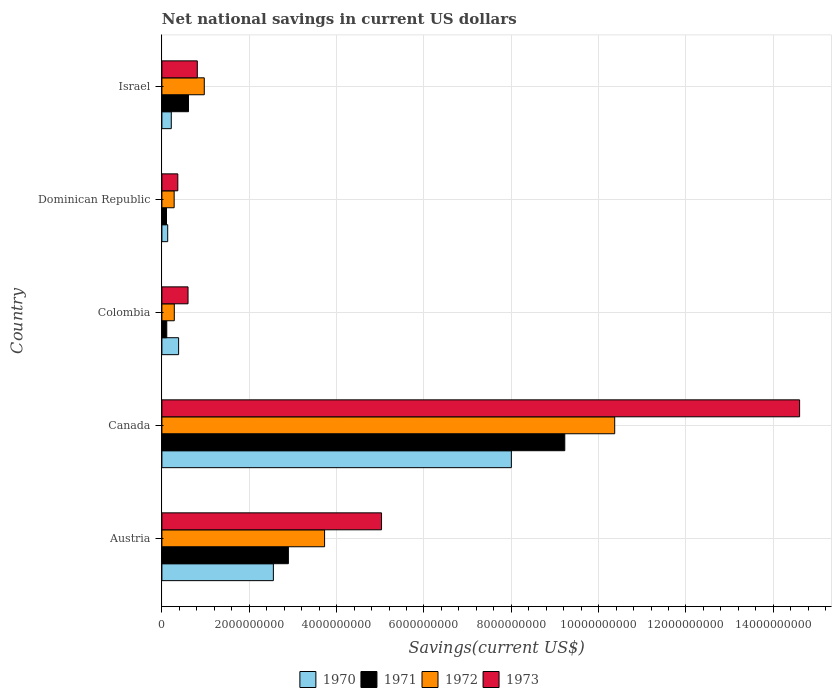How many different coloured bars are there?
Keep it short and to the point. 4. Are the number of bars per tick equal to the number of legend labels?
Provide a short and direct response. Yes. Are the number of bars on each tick of the Y-axis equal?
Ensure brevity in your answer.  Yes. How many bars are there on the 3rd tick from the top?
Your answer should be compact. 4. What is the label of the 4th group of bars from the top?
Ensure brevity in your answer.  Canada. In how many cases, is the number of bars for a given country not equal to the number of legend labels?
Your response must be concise. 0. What is the net national savings in 1970 in Dominican Republic?
Your response must be concise. 1.33e+08. Across all countries, what is the maximum net national savings in 1973?
Keep it short and to the point. 1.46e+1. Across all countries, what is the minimum net national savings in 1972?
Offer a very short reply. 2.80e+08. In which country was the net national savings in 1973 maximum?
Your answer should be very brief. Canada. In which country was the net national savings in 1972 minimum?
Provide a succinct answer. Dominican Republic. What is the total net national savings in 1973 in the graph?
Offer a terse response. 2.14e+1. What is the difference between the net national savings in 1973 in Canada and that in Israel?
Make the answer very short. 1.38e+1. What is the difference between the net national savings in 1971 in Israel and the net national savings in 1972 in Canada?
Provide a succinct answer. -9.76e+09. What is the average net national savings in 1973 per country?
Keep it short and to the point. 4.28e+09. What is the difference between the net national savings in 1970 and net national savings in 1971 in Colombia?
Offer a very short reply. 2.71e+08. What is the ratio of the net national savings in 1971 in Canada to that in Dominican Republic?
Your answer should be compact. 87.52. Is the difference between the net national savings in 1970 in Canada and Israel greater than the difference between the net national savings in 1971 in Canada and Israel?
Give a very brief answer. No. What is the difference between the highest and the second highest net national savings in 1972?
Your answer should be compact. 6.64e+09. What is the difference between the highest and the lowest net national savings in 1972?
Ensure brevity in your answer.  1.01e+1. Is it the case that in every country, the sum of the net national savings in 1970 and net national savings in 1973 is greater than the sum of net national savings in 1972 and net national savings in 1971?
Offer a terse response. No. What does the 2nd bar from the bottom in Canada represents?
Give a very brief answer. 1971. Is it the case that in every country, the sum of the net national savings in 1972 and net national savings in 1970 is greater than the net national savings in 1973?
Ensure brevity in your answer.  Yes. How many bars are there?
Your answer should be very brief. 20. Are all the bars in the graph horizontal?
Keep it short and to the point. Yes. How many countries are there in the graph?
Your answer should be very brief. 5. Are the values on the major ticks of X-axis written in scientific E-notation?
Provide a short and direct response. No. How many legend labels are there?
Give a very brief answer. 4. What is the title of the graph?
Keep it short and to the point. Net national savings in current US dollars. Does "2002" appear as one of the legend labels in the graph?
Ensure brevity in your answer.  No. What is the label or title of the X-axis?
Offer a terse response. Savings(current US$). What is the label or title of the Y-axis?
Offer a very short reply. Country. What is the Savings(current US$) of 1970 in Austria?
Give a very brief answer. 2.55e+09. What is the Savings(current US$) of 1971 in Austria?
Provide a short and direct response. 2.90e+09. What is the Savings(current US$) of 1972 in Austria?
Give a very brief answer. 3.73e+09. What is the Savings(current US$) of 1973 in Austria?
Your response must be concise. 5.03e+09. What is the Savings(current US$) of 1970 in Canada?
Ensure brevity in your answer.  8.00e+09. What is the Savings(current US$) of 1971 in Canada?
Offer a very short reply. 9.23e+09. What is the Savings(current US$) of 1972 in Canada?
Give a very brief answer. 1.04e+1. What is the Savings(current US$) in 1973 in Canada?
Give a very brief answer. 1.46e+1. What is the Savings(current US$) of 1970 in Colombia?
Offer a very short reply. 3.83e+08. What is the Savings(current US$) of 1971 in Colombia?
Offer a very short reply. 1.11e+08. What is the Savings(current US$) of 1972 in Colombia?
Your response must be concise. 2.84e+08. What is the Savings(current US$) of 1973 in Colombia?
Provide a short and direct response. 5.98e+08. What is the Savings(current US$) in 1970 in Dominican Republic?
Give a very brief answer. 1.33e+08. What is the Savings(current US$) in 1971 in Dominican Republic?
Make the answer very short. 1.05e+08. What is the Savings(current US$) in 1972 in Dominican Republic?
Give a very brief answer. 2.80e+08. What is the Savings(current US$) in 1973 in Dominican Republic?
Provide a succinct answer. 3.65e+08. What is the Savings(current US$) of 1970 in Israel?
Keep it short and to the point. 2.15e+08. What is the Savings(current US$) of 1971 in Israel?
Ensure brevity in your answer.  6.09e+08. What is the Savings(current US$) of 1972 in Israel?
Your answer should be compact. 9.71e+08. What is the Savings(current US$) in 1973 in Israel?
Offer a very short reply. 8.11e+08. Across all countries, what is the maximum Savings(current US$) in 1970?
Your answer should be compact. 8.00e+09. Across all countries, what is the maximum Savings(current US$) of 1971?
Your response must be concise. 9.23e+09. Across all countries, what is the maximum Savings(current US$) of 1972?
Offer a terse response. 1.04e+1. Across all countries, what is the maximum Savings(current US$) in 1973?
Your answer should be very brief. 1.46e+1. Across all countries, what is the minimum Savings(current US$) of 1970?
Keep it short and to the point. 1.33e+08. Across all countries, what is the minimum Savings(current US$) in 1971?
Your response must be concise. 1.05e+08. Across all countries, what is the minimum Savings(current US$) of 1972?
Keep it short and to the point. 2.80e+08. Across all countries, what is the minimum Savings(current US$) in 1973?
Provide a short and direct response. 3.65e+08. What is the total Savings(current US$) of 1970 in the graph?
Keep it short and to the point. 1.13e+1. What is the total Savings(current US$) in 1971 in the graph?
Keep it short and to the point. 1.29e+1. What is the total Savings(current US$) in 1972 in the graph?
Provide a short and direct response. 1.56e+1. What is the total Savings(current US$) of 1973 in the graph?
Offer a very short reply. 2.14e+1. What is the difference between the Savings(current US$) in 1970 in Austria and that in Canada?
Provide a succinct answer. -5.45e+09. What is the difference between the Savings(current US$) of 1971 in Austria and that in Canada?
Offer a terse response. -6.33e+09. What is the difference between the Savings(current US$) in 1972 in Austria and that in Canada?
Give a very brief answer. -6.64e+09. What is the difference between the Savings(current US$) in 1973 in Austria and that in Canada?
Provide a succinct answer. -9.57e+09. What is the difference between the Savings(current US$) in 1970 in Austria and that in Colombia?
Give a very brief answer. 2.17e+09. What is the difference between the Savings(current US$) in 1971 in Austria and that in Colombia?
Offer a very short reply. 2.78e+09. What is the difference between the Savings(current US$) of 1972 in Austria and that in Colombia?
Provide a short and direct response. 3.44e+09. What is the difference between the Savings(current US$) in 1973 in Austria and that in Colombia?
Give a very brief answer. 4.43e+09. What is the difference between the Savings(current US$) in 1970 in Austria and that in Dominican Republic?
Make the answer very short. 2.42e+09. What is the difference between the Savings(current US$) of 1971 in Austria and that in Dominican Republic?
Keep it short and to the point. 2.79e+09. What is the difference between the Savings(current US$) of 1972 in Austria and that in Dominican Republic?
Your response must be concise. 3.44e+09. What is the difference between the Savings(current US$) of 1973 in Austria and that in Dominican Republic?
Give a very brief answer. 4.66e+09. What is the difference between the Savings(current US$) in 1970 in Austria and that in Israel?
Give a very brief answer. 2.34e+09. What is the difference between the Savings(current US$) in 1971 in Austria and that in Israel?
Keep it short and to the point. 2.29e+09. What is the difference between the Savings(current US$) in 1972 in Austria and that in Israel?
Ensure brevity in your answer.  2.75e+09. What is the difference between the Savings(current US$) of 1973 in Austria and that in Israel?
Ensure brevity in your answer.  4.22e+09. What is the difference between the Savings(current US$) of 1970 in Canada and that in Colombia?
Offer a terse response. 7.62e+09. What is the difference between the Savings(current US$) of 1971 in Canada and that in Colombia?
Offer a very short reply. 9.11e+09. What is the difference between the Savings(current US$) in 1972 in Canada and that in Colombia?
Make the answer very short. 1.01e+1. What is the difference between the Savings(current US$) in 1973 in Canada and that in Colombia?
Provide a succinct answer. 1.40e+1. What is the difference between the Savings(current US$) of 1970 in Canada and that in Dominican Republic?
Your answer should be very brief. 7.87e+09. What is the difference between the Savings(current US$) of 1971 in Canada and that in Dominican Republic?
Your response must be concise. 9.12e+09. What is the difference between the Savings(current US$) in 1972 in Canada and that in Dominican Republic?
Keep it short and to the point. 1.01e+1. What is the difference between the Savings(current US$) of 1973 in Canada and that in Dominican Republic?
Make the answer very short. 1.42e+1. What is the difference between the Savings(current US$) of 1970 in Canada and that in Israel?
Offer a very short reply. 7.79e+09. What is the difference between the Savings(current US$) of 1971 in Canada and that in Israel?
Give a very brief answer. 8.62e+09. What is the difference between the Savings(current US$) of 1972 in Canada and that in Israel?
Give a very brief answer. 9.40e+09. What is the difference between the Savings(current US$) in 1973 in Canada and that in Israel?
Offer a very short reply. 1.38e+1. What is the difference between the Savings(current US$) of 1970 in Colombia and that in Dominican Republic?
Your answer should be very brief. 2.50e+08. What is the difference between the Savings(current US$) in 1971 in Colombia and that in Dominican Republic?
Make the answer very short. 6.03e+06. What is the difference between the Savings(current US$) of 1972 in Colombia and that in Dominican Republic?
Offer a terse response. 3.48e+06. What is the difference between the Savings(current US$) in 1973 in Colombia and that in Dominican Republic?
Make the answer very short. 2.34e+08. What is the difference between the Savings(current US$) of 1970 in Colombia and that in Israel?
Provide a succinct answer. 1.68e+08. What is the difference between the Savings(current US$) in 1971 in Colombia and that in Israel?
Provide a succinct answer. -4.97e+08. What is the difference between the Savings(current US$) in 1972 in Colombia and that in Israel?
Ensure brevity in your answer.  -6.87e+08. What is the difference between the Savings(current US$) of 1973 in Colombia and that in Israel?
Provide a succinct answer. -2.12e+08. What is the difference between the Savings(current US$) of 1970 in Dominican Republic and that in Israel?
Ensure brevity in your answer.  -8.19e+07. What is the difference between the Savings(current US$) in 1971 in Dominican Republic and that in Israel?
Keep it short and to the point. -5.03e+08. What is the difference between the Savings(current US$) in 1972 in Dominican Republic and that in Israel?
Offer a terse response. -6.90e+08. What is the difference between the Savings(current US$) in 1973 in Dominican Republic and that in Israel?
Give a very brief answer. -4.46e+08. What is the difference between the Savings(current US$) of 1970 in Austria and the Savings(current US$) of 1971 in Canada?
Provide a short and direct response. -6.67e+09. What is the difference between the Savings(current US$) in 1970 in Austria and the Savings(current US$) in 1972 in Canada?
Your answer should be compact. -7.82e+09. What is the difference between the Savings(current US$) of 1970 in Austria and the Savings(current US$) of 1973 in Canada?
Make the answer very short. -1.20e+1. What is the difference between the Savings(current US$) in 1971 in Austria and the Savings(current US$) in 1972 in Canada?
Provide a short and direct response. -7.47e+09. What is the difference between the Savings(current US$) in 1971 in Austria and the Savings(current US$) in 1973 in Canada?
Ensure brevity in your answer.  -1.17e+1. What is the difference between the Savings(current US$) in 1972 in Austria and the Savings(current US$) in 1973 in Canada?
Ensure brevity in your answer.  -1.09e+1. What is the difference between the Savings(current US$) of 1970 in Austria and the Savings(current US$) of 1971 in Colombia?
Offer a very short reply. 2.44e+09. What is the difference between the Savings(current US$) in 1970 in Austria and the Savings(current US$) in 1972 in Colombia?
Ensure brevity in your answer.  2.27e+09. What is the difference between the Savings(current US$) of 1970 in Austria and the Savings(current US$) of 1973 in Colombia?
Provide a succinct answer. 1.95e+09. What is the difference between the Savings(current US$) in 1971 in Austria and the Savings(current US$) in 1972 in Colombia?
Provide a succinct answer. 2.61e+09. What is the difference between the Savings(current US$) of 1971 in Austria and the Savings(current US$) of 1973 in Colombia?
Give a very brief answer. 2.30e+09. What is the difference between the Savings(current US$) in 1972 in Austria and the Savings(current US$) in 1973 in Colombia?
Your response must be concise. 3.13e+09. What is the difference between the Savings(current US$) in 1970 in Austria and the Savings(current US$) in 1971 in Dominican Republic?
Your response must be concise. 2.45e+09. What is the difference between the Savings(current US$) in 1970 in Austria and the Savings(current US$) in 1972 in Dominican Republic?
Provide a short and direct response. 2.27e+09. What is the difference between the Savings(current US$) of 1970 in Austria and the Savings(current US$) of 1973 in Dominican Republic?
Offer a terse response. 2.19e+09. What is the difference between the Savings(current US$) in 1971 in Austria and the Savings(current US$) in 1972 in Dominican Republic?
Your answer should be very brief. 2.62e+09. What is the difference between the Savings(current US$) of 1971 in Austria and the Savings(current US$) of 1973 in Dominican Republic?
Provide a succinct answer. 2.53e+09. What is the difference between the Savings(current US$) of 1972 in Austria and the Savings(current US$) of 1973 in Dominican Republic?
Your answer should be compact. 3.36e+09. What is the difference between the Savings(current US$) of 1970 in Austria and the Savings(current US$) of 1971 in Israel?
Your response must be concise. 1.94e+09. What is the difference between the Savings(current US$) of 1970 in Austria and the Savings(current US$) of 1972 in Israel?
Offer a terse response. 1.58e+09. What is the difference between the Savings(current US$) in 1970 in Austria and the Savings(current US$) in 1973 in Israel?
Ensure brevity in your answer.  1.74e+09. What is the difference between the Savings(current US$) in 1971 in Austria and the Savings(current US$) in 1972 in Israel?
Your answer should be compact. 1.93e+09. What is the difference between the Savings(current US$) in 1971 in Austria and the Savings(current US$) in 1973 in Israel?
Your answer should be compact. 2.09e+09. What is the difference between the Savings(current US$) in 1972 in Austria and the Savings(current US$) in 1973 in Israel?
Make the answer very short. 2.91e+09. What is the difference between the Savings(current US$) of 1970 in Canada and the Savings(current US$) of 1971 in Colombia?
Provide a succinct answer. 7.89e+09. What is the difference between the Savings(current US$) in 1970 in Canada and the Savings(current US$) in 1972 in Colombia?
Make the answer very short. 7.72e+09. What is the difference between the Savings(current US$) in 1970 in Canada and the Savings(current US$) in 1973 in Colombia?
Offer a very short reply. 7.40e+09. What is the difference between the Savings(current US$) of 1971 in Canada and the Savings(current US$) of 1972 in Colombia?
Make the answer very short. 8.94e+09. What is the difference between the Savings(current US$) of 1971 in Canada and the Savings(current US$) of 1973 in Colombia?
Your answer should be very brief. 8.63e+09. What is the difference between the Savings(current US$) in 1972 in Canada and the Savings(current US$) in 1973 in Colombia?
Provide a succinct answer. 9.77e+09. What is the difference between the Savings(current US$) of 1970 in Canada and the Savings(current US$) of 1971 in Dominican Republic?
Your answer should be very brief. 7.90e+09. What is the difference between the Savings(current US$) of 1970 in Canada and the Savings(current US$) of 1972 in Dominican Republic?
Ensure brevity in your answer.  7.72e+09. What is the difference between the Savings(current US$) in 1970 in Canada and the Savings(current US$) in 1973 in Dominican Republic?
Make the answer very short. 7.64e+09. What is the difference between the Savings(current US$) of 1971 in Canada and the Savings(current US$) of 1972 in Dominican Republic?
Offer a very short reply. 8.94e+09. What is the difference between the Savings(current US$) of 1971 in Canada and the Savings(current US$) of 1973 in Dominican Republic?
Provide a short and direct response. 8.86e+09. What is the difference between the Savings(current US$) of 1972 in Canada and the Savings(current US$) of 1973 in Dominican Republic?
Your response must be concise. 1.00e+1. What is the difference between the Savings(current US$) of 1970 in Canada and the Savings(current US$) of 1971 in Israel?
Offer a terse response. 7.39e+09. What is the difference between the Savings(current US$) in 1970 in Canada and the Savings(current US$) in 1972 in Israel?
Provide a short and direct response. 7.03e+09. What is the difference between the Savings(current US$) of 1970 in Canada and the Savings(current US$) of 1973 in Israel?
Provide a short and direct response. 7.19e+09. What is the difference between the Savings(current US$) in 1971 in Canada and the Savings(current US$) in 1972 in Israel?
Provide a succinct answer. 8.25e+09. What is the difference between the Savings(current US$) of 1971 in Canada and the Savings(current US$) of 1973 in Israel?
Give a very brief answer. 8.41e+09. What is the difference between the Savings(current US$) in 1972 in Canada and the Savings(current US$) in 1973 in Israel?
Give a very brief answer. 9.56e+09. What is the difference between the Savings(current US$) in 1970 in Colombia and the Savings(current US$) in 1971 in Dominican Republic?
Your response must be concise. 2.77e+08. What is the difference between the Savings(current US$) of 1970 in Colombia and the Savings(current US$) of 1972 in Dominican Republic?
Give a very brief answer. 1.02e+08. What is the difference between the Savings(current US$) of 1970 in Colombia and the Savings(current US$) of 1973 in Dominican Republic?
Your response must be concise. 1.82e+07. What is the difference between the Savings(current US$) of 1971 in Colombia and the Savings(current US$) of 1972 in Dominican Republic?
Your answer should be very brief. -1.69e+08. What is the difference between the Savings(current US$) of 1971 in Colombia and the Savings(current US$) of 1973 in Dominican Republic?
Keep it short and to the point. -2.53e+08. What is the difference between the Savings(current US$) in 1972 in Colombia and the Savings(current US$) in 1973 in Dominican Republic?
Your answer should be very brief. -8.05e+07. What is the difference between the Savings(current US$) of 1970 in Colombia and the Savings(current US$) of 1971 in Israel?
Your response must be concise. -2.26e+08. What is the difference between the Savings(current US$) in 1970 in Colombia and the Savings(current US$) in 1972 in Israel?
Provide a succinct answer. -5.88e+08. What is the difference between the Savings(current US$) in 1970 in Colombia and the Savings(current US$) in 1973 in Israel?
Give a very brief answer. -4.28e+08. What is the difference between the Savings(current US$) in 1971 in Colombia and the Savings(current US$) in 1972 in Israel?
Offer a very short reply. -8.59e+08. What is the difference between the Savings(current US$) of 1971 in Colombia and the Savings(current US$) of 1973 in Israel?
Keep it short and to the point. -6.99e+08. What is the difference between the Savings(current US$) in 1972 in Colombia and the Savings(current US$) in 1973 in Israel?
Provide a succinct answer. -5.27e+08. What is the difference between the Savings(current US$) of 1970 in Dominican Republic and the Savings(current US$) of 1971 in Israel?
Offer a very short reply. -4.76e+08. What is the difference between the Savings(current US$) in 1970 in Dominican Republic and the Savings(current US$) in 1972 in Israel?
Your response must be concise. -8.38e+08. What is the difference between the Savings(current US$) of 1970 in Dominican Republic and the Savings(current US$) of 1973 in Israel?
Your answer should be very brief. -6.78e+08. What is the difference between the Savings(current US$) in 1971 in Dominican Republic and the Savings(current US$) in 1972 in Israel?
Keep it short and to the point. -8.65e+08. What is the difference between the Savings(current US$) in 1971 in Dominican Republic and the Savings(current US$) in 1973 in Israel?
Provide a short and direct response. -7.05e+08. What is the difference between the Savings(current US$) of 1972 in Dominican Republic and the Savings(current US$) of 1973 in Israel?
Ensure brevity in your answer.  -5.30e+08. What is the average Savings(current US$) in 1970 per country?
Provide a succinct answer. 2.26e+09. What is the average Savings(current US$) in 1971 per country?
Offer a terse response. 2.59e+09. What is the average Savings(current US$) in 1972 per country?
Your answer should be compact. 3.13e+09. What is the average Savings(current US$) of 1973 per country?
Your response must be concise. 4.28e+09. What is the difference between the Savings(current US$) of 1970 and Savings(current US$) of 1971 in Austria?
Your response must be concise. -3.44e+08. What is the difference between the Savings(current US$) in 1970 and Savings(current US$) in 1972 in Austria?
Your answer should be compact. -1.17e+09. What is the difference between the Savings(current US$) of 1970 and Savings(current US$) of 1973 in Austria?
Your answer should be compact. -2.48e+09. What is the difference between the Savings(current US$) of 1971 and Savings(current US$) of 1972 in Austria?
Provide a short and direct response. -8.29e+08. What is the difference between the Savings(current US$) in 1971 and Savings(current US$) in 1973 in Austria?
Give a very brief answer. -2.13e+09. What is the difference between the Savings(current US$) of 1972 and Savings(current US$) of 1973 in Austria?
Your response must be concise. -1.30e+09. What is the difference between the Savings(current US$) in 1970 and Savings(current US$) in 1971 in Canada?
Provide a short and direct response. -1.22e+09. What is the difference between the Savings(current US$) in 1970 and Savings(current US$) in 1972 in Canada?
Provide a succinct answer. -2.37e+09. What is the difference between the Savings(current US$) in 1970 and Savings(current US$) in 1973 in Canada?
Ensure brevity in your answer.  -6.60e+09. What is the difference between the Savings(current US$) in 1971 and Savings(current US$) in 1972 in Canada?
Make the answer very short. -1.14e+09. What is the difference between the Savings(current US$) of 1971 and Savings(current US$) of 1973 in Canada?
Ensure brevity in your answer.  -5.38e+09. What is the difference between the Savings(current US$) of 1972 and Savings(current US$) of 1973 in Canada?
Your answer should be compact. -4.23e+09. What is the difference between the Savings(current US$) in 1970 and Savings(current US$) in 1971 in Colombia?
Give a very brief answer. 2.71e+08. What is the difference between the Savings(current US$) of 1970 and Savings(current US$) of 1972 in Colombia?
Provide a short and direct response. 9.87e+07. What is the difference between the Savings(current US$) in 1970 and Savings(current US$) in 1973 in Colombia?
Your response must be concise. -2.16e+08. What is the difference between the Savings(current US$) in 1971 and Savings(current US$) in 1972 in Colombia?
Offer a terse response. -1.73e+08. What is the difference between the Savings(current US$) in 1971 and Savings(current US$) in 1973 in Colombia?
Offer a terse response. -4.87e+08. What is the difference between the Savings(current US$) in 1972 and Savings(current US$) in 1973 in Colombia?
Provide a short and direct response. -3.14e+08. What is the difference between the Savings(current US$) of 1970 and Savings(current US$) of 1971 in Dominican Republic?
Offer a terse response. 2.74e+07. What is the difference between the Savings(current US$) in 1970 and Savings(current US$) in 1972 in Dominican Republic?
Keep it short and to the point. -1.48e+08. What is the difference between the Savings(current US$) of 1970 and Savings(current US$) of 1973 in Dominican Republic?
Provide a short and direct response. -2.32e+08. What is the difference between the Savings(current US$) in 1971 and Savings(current US$) in 1972 in Dominican Republic?
Offer a very short reply. -1.75e+08. What is the difference between the Savings(current US$) of 1971 and Savings(current US$) of 1973 in Dominican Republic?
Make the answer very short. -2.59e+08. What is the difference between the Savings(current US$) of 1972 and Savings(current US$) of 1973 in Dominican Republic?
Your answer should be compact. -8.40e+07. What is the difference between the Savings(current US$) of 1970 and Savings(current US$) of 1971 in Israel?
Keep it short and to the point. -3.94e+08. What is the difference between the Savings(current US$) of 1970 and Savings(current US$) of 1972 in Israel?
Offer a very short reply. -7.56e+08. What is the difference between the Savings(current US$) of 1970 and Savings(current US$) of 1973 in Israel?
Offer a terse response. -5.96e+08. What is the difference between the Savings(current US$) of 1971 and Savings(current US$) of 1972 in Israel?
Offer a very short reply. -3.62e+08. What is the difference between the Savings(current US$) in 1971 and Savings(current US$) in 1973 in Israel?
Offer a terse response. -2.02e+08. What is the difference between the Savings(current US$) in 1972 and Savings(current US$) in 1973 in Israel?
Your answer should be very brief. 1.60e+08. What is the ratio of the Savings(current US$) in 1970 in Austria to that in Canada?
Provide a succinct answer. 0.32. What is the ratio of the Savings(current US$) of 1971 in Austria to that in Canada?
Your answer should be very brief. 0.31. What is the ratio of the Savings(current US$) of 1972 in Austria to that in Canada?
Make the answer very short. 0.36. What is the ratio of the Savings(current US$) of 1973 in Austria to that in Canada?
Provide a short and direct response. 0.34. What is the ratio of the Savings(current US$) in 1970 in Austria to that in Colombia?
Make the answer very short. 6.67. What is the ratio of the Savings(current US$) of 1971 in Austria to that in Colombia?
Provide a short and direct response. 25.99. What is the ratio of the Savings(current US$) of 1972 in Austria to that in Colombia?
Provide a succinct answer. 13.12. What is the ratio of the Savings(current US$) in 1973 in Austria to that in Colombia?
Ensure brevity in your answer.  8.4. What is the ratio of the Savings(current US$) of 1970 in Austria to that in Dominican Republic?
Provide a short and direct response. 19.23. What is the ratio of the Savings(current US$) of 1971 in Austria to that in Dominican Republic?
Your answer should be very brief. 27.48. What is the ratio of the Savings(current US$) in 1972 in Austria to that in Dominican Republic?
Offer a terse response. 13.28. What is the ratio of the Savings(current US$) of 1973 in Austria to that in Dominican Republic?
Provide a succinct answer. 13.8. What is the ratio of the Savings(current US$) of 1970 in Austria to that in Israel?
Make the answer very short. 11.89. What is the ratio of the Savings(current US$) of 1971 in Austria to that in Israel?
Your answer should be very brief. 4.76. What is the ratio of the Savings(current US$) of 1972 in Austria to that in Israel?
Provide a short and direct response. 3.84. What is the ratio of the Savings(current US$) of 1973 in Austria to that in Israel?
Your answer should be compact. 6.2. What is the ratio of the Savings(current US$) in 1970 in Canada to that in Colombia?
Your response must be concise. 20.91. What is the ratio of the Savings(current US$) of 1971 in Canada to that in Colombia?
Provide a short and direct response. 82.79. What is the ratio of the Savings(current US$) of 1972 in Canada to that in Colombia?
Provide a short and direct response. 36.51. What is the ratio of the Savings(current US$) of 1973 in Canada to that in Colombia?
Offer a terse response. 24.4. What is the ratio of the Savings(current US$) of 1970 in Canada to that in Dominican Republic?
Give a very brief answer. 60.27. What is the ratio of the Savings(current US$) in 1971 in Canada to that in Dominican Republic?
Give a very brief answer. 87.52. What is the ratio of the Savings(current US$) of 1972 in Canada to that in Dominican Republic?
Offer a terse response. 36.96. What is the ratio of the Savings(current US$) of 1973 in Canada to that in Dominican Republic?
Your answer should be compact. 40.06. What is the ratio of the Savings(current US$) of 1970 in Canada to that in Israel?
Keep it short and to the point. 37.28. What is the ratio of the Savings(current US$) in 1971 in Canada to that in Israel?
Make the answer very short. 15.16. What is the ratio of the Savings(current US$) of 1972 in Canada to that in Israel?
Keep it short and to the point. 10.68. What is the ratio of the Savings(current US$) in 1973 in Canada to that in Israel?
Give a very brief answer. 18.01. What is the ratio of the Savings(current US$) in 1970 in Colombia to that in Dominican Republic?
Offer a terse response. 2.88. What is the ratio of the Savings(current US$) of 1971 in Colombia to that in Dominican Republic?
Offer a very short reply. 1.06. What is the ratio of the Savings(current US$) of 1972 in Colombia to that in Dominican Republic?
Make the answer very short. 1.01. What is the ratio of the Savings(current US$) of 1973 in Colombia to that in Dominican Republic?
Your answer should be very brief. 1.64. What is the ratio of the Savings(current US$) of 1970 in Colombia to that in Israel?
Your answer should be very brief. 1.78. What is the ratio of the Savings(current US$) of 1971 in Colombia to that in Israel?
Keep it short and to the point. 0.18. What is the ratio of the Savings(current US$) in 1972 in Colombia to that in Israel?
Make the answer very short. 0.29. What is the ratio of the Savings(current US$) of 1973 in Colombia to that in Israel?
Your answer should be very brief. 0.74. What is the ratio of the Savings(current US$) of 1970 in Dominican Republic to that in Israel?
Keep it short and to the point. 0.62. What is the ratio of the Savings(current US$) in 1971 in Dominican Republic to that in Israel?
Ensure brevity in your answer.  0.17. What is the ratio of the Savings(current US$) of 1972 in Dominican Republic to that in Israel?
Your response must be concise. 0.29. What is the ratio of the Savings(current US$) of 1973 in Dominican Republic to that in Israel?
Your answer should be compact. 0.45. What is the difference between the highest and the second highest Savings(current US$) of 1970?
Offer a terse response. 5.45e+09. What is the difference between the highest and the second highest Savings(current US$) of 1971?
Keep it short and to the point. 6.33e+09. What is the difference between the highest and the second highest Savings(current US$) in 1972?
Your answer should be very brief. 6.64e+09. What is the difference between the highest and the second highest Savings(current US$) in 1973?
Provide a succinct answer. 9.57e+09. What is the difference between the highest and the lowest Savings(current US$) in 1970?
Give a very brief answer. 7.87e+09. What is the difference between the highest and the lowest Savings(current US$) of 1971?
Give a very brief answer. 9.12e+09. What is the difference between the highest and the lowest Savings(current US$) in 1972?
Offer a terse response. 1.01e+1. What is the difference between the highest and the lowest Savings(current US$) in 1973?
Your response must be concise. 1.42e+1. 